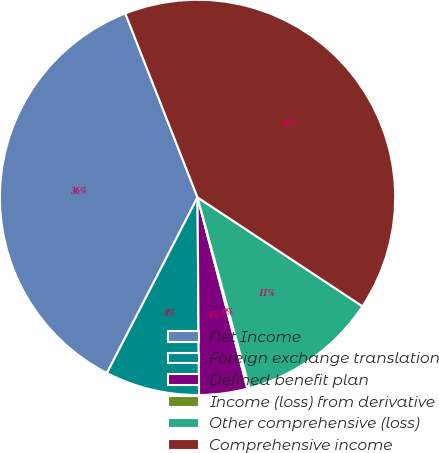Convert chart. <chart><loc_0><loc_0><loc_500><loc_500><pie_chart><fcel>Net Income<fcel>Foreign exchange translation<fcel>Defined benefit plan<fcel>Income (loss) from derivative<fcel>Other comprehensive (loss)<fcel>Comprehensive income<nl><fcel>36.47%<fcel>7.7%<fcel>3.94%<fcel>0.18%<fcel>11.47%<fcel>40.24%<nl></chart> 